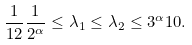Convert formula to latex. <formula><loc_0><loc_0><loc_500><loc_500>\frac { 1 } { 1 2 } \frac { 1 } { 2 ^ { \alpha } } \leq \lambda _ { 1 } \leq \lambda _ { 2 } \leq 3 ^ { \alpha } 1 0 .</formula> 